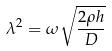<formula> <loc_0><loc_0><loc_500><loc_500>\lambda ^ { 2 } = \omega \sqrt { \frac { 2 \rho h } { D } }</formula> 